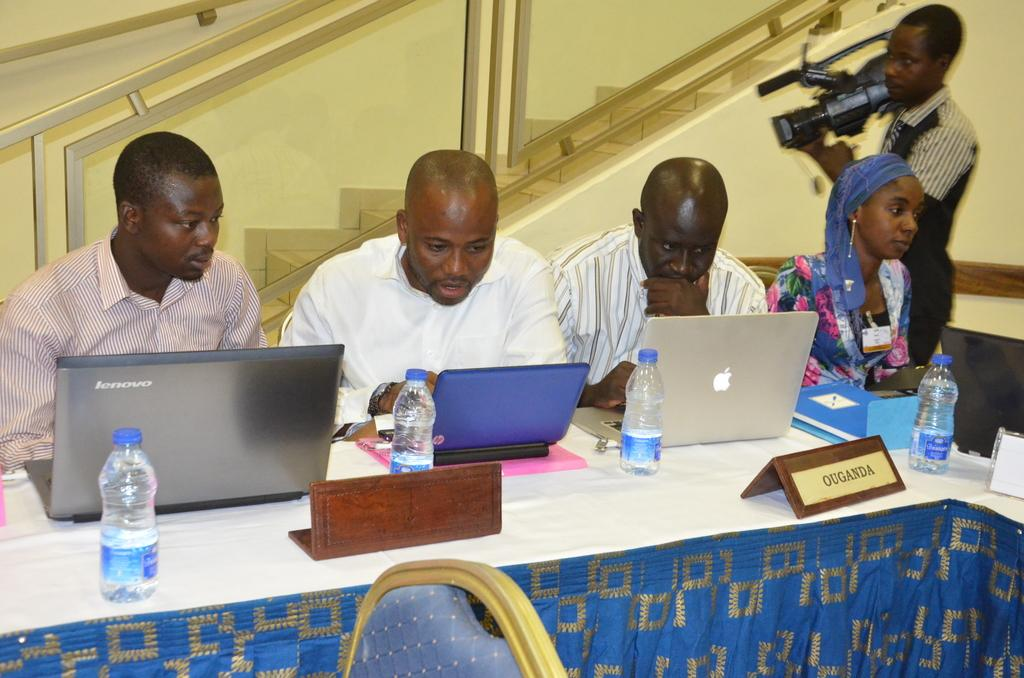<image>
Share a concise interpretation of the image provided. A man on a Lenovo laptop watching another man on his laptop 